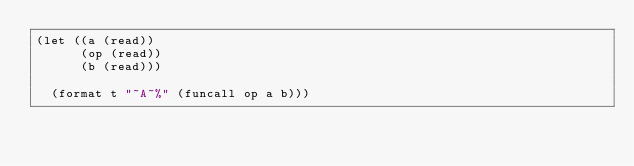<code> <loc_0><loc_0><loc_500><loc_500><_Lisp_>(let ((a (read))
      (op (read))
      (b (read)))

  (format t "~A~%" (funcall op a b)))
</code> 